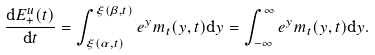<formula> <loc_0><loc_0><loc_500><loc_500>\frac { \mathrm d E ^ { u } _ { + } ( t ) } { \mathrm d t } = \int _ { \xi ( \alpha , t ) } ^ { \xi ( \beta , t ) } e ^ { y } m _ { t } ( y , t ) \mathrm d y = \int _ { - \infty } ^ { \infty } e ^ { y } m _ { t } ( y , t ) \mathrm d y .</formula> 